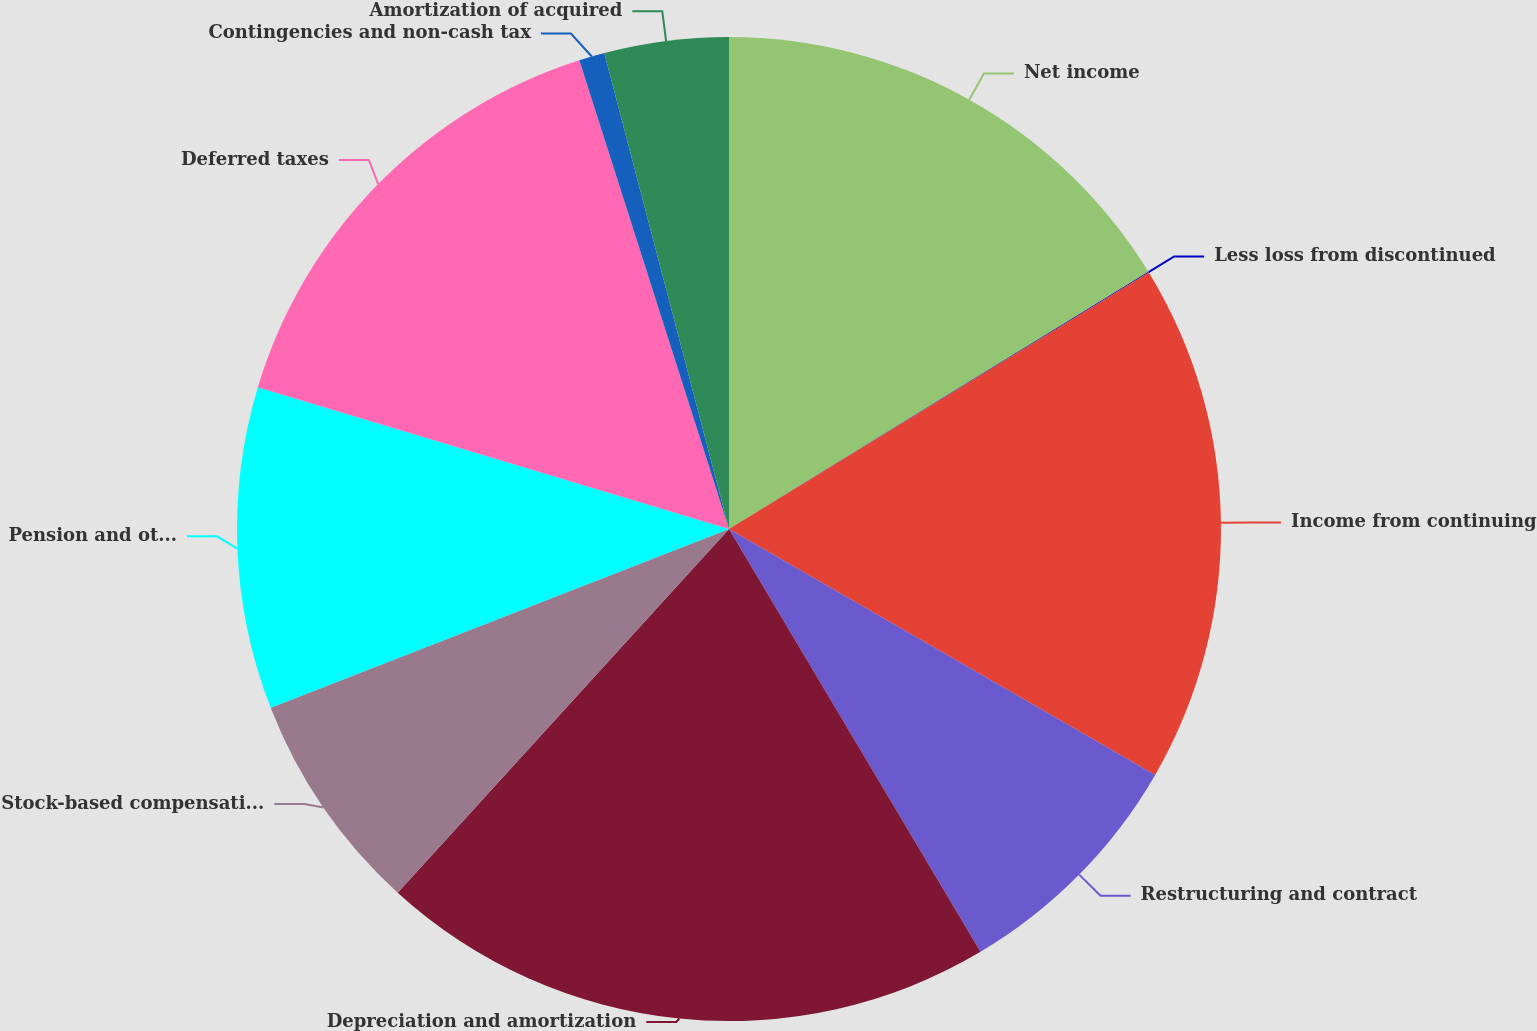Convert chart. <chart><loc_0><loc_0><loc_500><loc_500><pie_chart><fcel>Net income<fcel>Less loss from discontinued<fcel>Income from continuing<fcel>Restructuring and contract<fcel>Depreciation and amortization<fcel>Stock-based compensation<fcel>Pension and other<fcel>Deferred taxes<fcel>Contingencies and non-cash tax<fcel>Amortization of acquired<nl><fcel>16.24%<fcel>0.03%<fcel>17.06%<fcel>8.13%<fcel>20.3%<fcel>7.32%<fcel>10.57%<fcel>15.43%<fcel>0.84%<fcel>4.08%<nl></chart> 